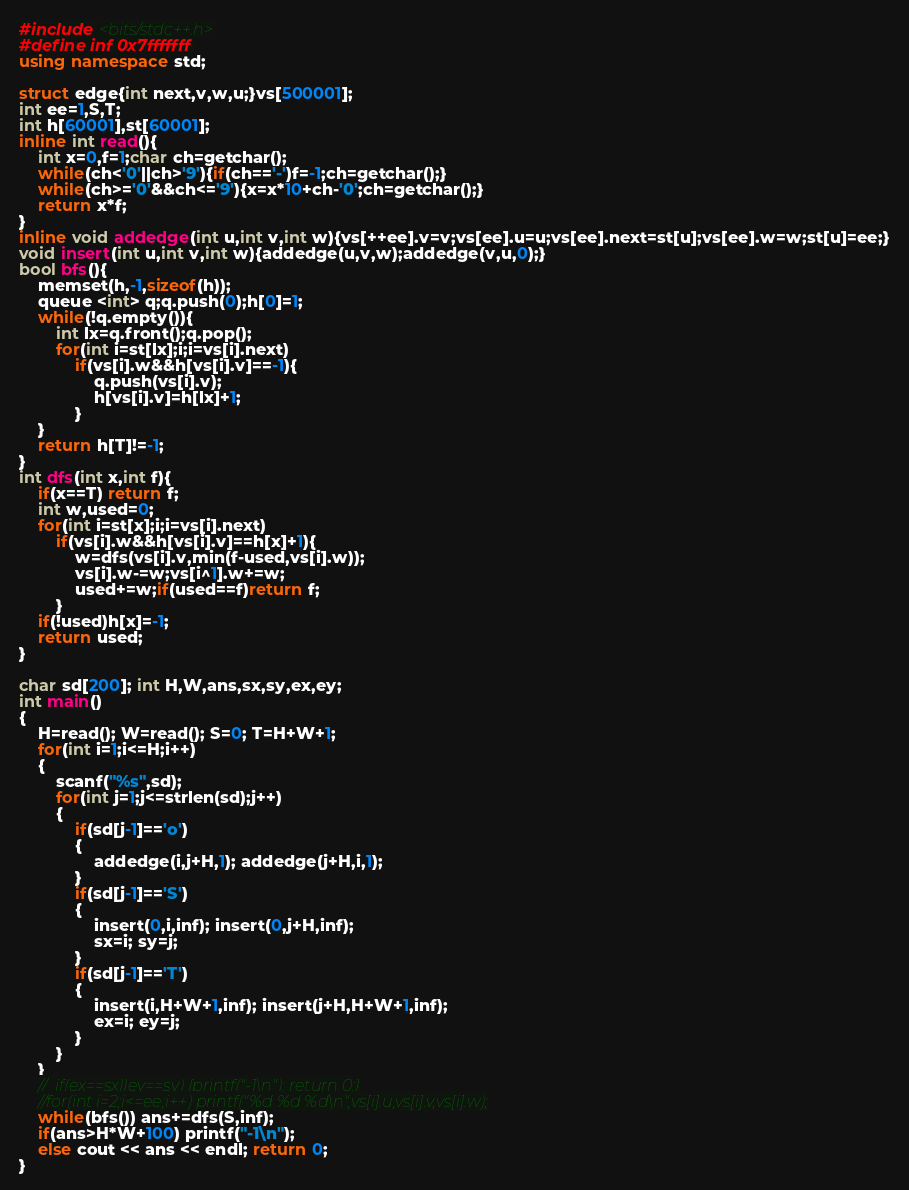<code> <loc_0><loc_0><loc_500><loc_500><_C++_>#include <bits/stdc++.h>
#define inf 0x7fffffff
using namespace std;

struct edge{int next,v,w,u;}vs[500001];
int ee=1,S,T;
int h[60001],st[60001];
inline int read(){
    int x=0,f=1;char ch=getchar();
    while(ch<'0'||ch>'9'){if(ch=='-')f=-1;ch=getchar();}
    while(ch>='0'&&ch<='9'){x=x*10+ch-'0';ch=getchar();}
    return x*f;
}
inline void addedge(int u,int v,int w){vs[++ee].v=v;vs[ee].u=u;vs[ee].next=st[u];vs[ee].w=w;st[u]=ee;}
void insert(int u,int v,int w){addedge(u,v,w);addedge(v,u,0);}
bool bfs(){
    memset(h,-1,sizeof(h));
    queue <int> q;q.push(0);h[0]=1;
    while(!q.empty()){
        int lx=q.front();q.pop();
        for(int i=st[lx];i;i=vs[i].next)
            if(vs[i].w&&h[vs[i].v]==-1){
                q.push(vs[i].v);
                h[vs[i].v]=h[lx]+1;
            }
    }
    return h[T]!=-1;
}
int dfs(int x,int f){
    if(x==T) return f;
    int w,used=0;
    for(int i=st[x];i;i=vs[i].next)
        if(vs[i].w&&h[vs[i].v]==h[x]+1){
            w=dfs(vs[i].v,min(f-used,vs[i].w));
            vs[i].w-=w;vs[i^1].w+=w;
            used+=w;if(used==f)return f;
        }
    if(!used)h[x]=-1;
    return used;
}

char sd[200]; int H,W,ans,sx,sy,ex,ey;
int main()
{
	H=read(); W=read(); S=0; T=H+W+1;
	for(int i=1;i<=H;i++)
	{
		scanf("%s",sd);
		for(int j=1;j<=strlen(sd);j++)
		{
			if(sd[j-1]=='o')
			{
				addedge(i,j+H,1); addedge(j+H,i,1);
			}
			if(sd[j-1]=='S')
			{
				insert(0,i,inf); insert(0,j+H,inf);
				sx=i; sy=j;
			}
			if(sd[j-1]=='T')
			{
				insert(i,H+W+1,inf); insert(j+H,H+W+1,inf);
				ex=i; ey=j;
			}
		}
	}
	//	if(ex==sx||ey==sy) {printf("-1\n"); return 0;}
	//for(int i=2;i<=ee;i++) printf("%d %d %d\n",vs[i].u,vs[i].v,vs[i].w);
	while(bfs()) ans+=dfs(S,inf);
	if(ans>H*W+100) printf("-1\n");
	else cout << ans << endl; return 0;
}</code> 